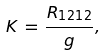Convert formula to latex. <formula><loc_0><loc_0><loc_500><loc_500>K \, = \, \frac { R _ { 1 2 1 2 } } { g } ,</formula> 